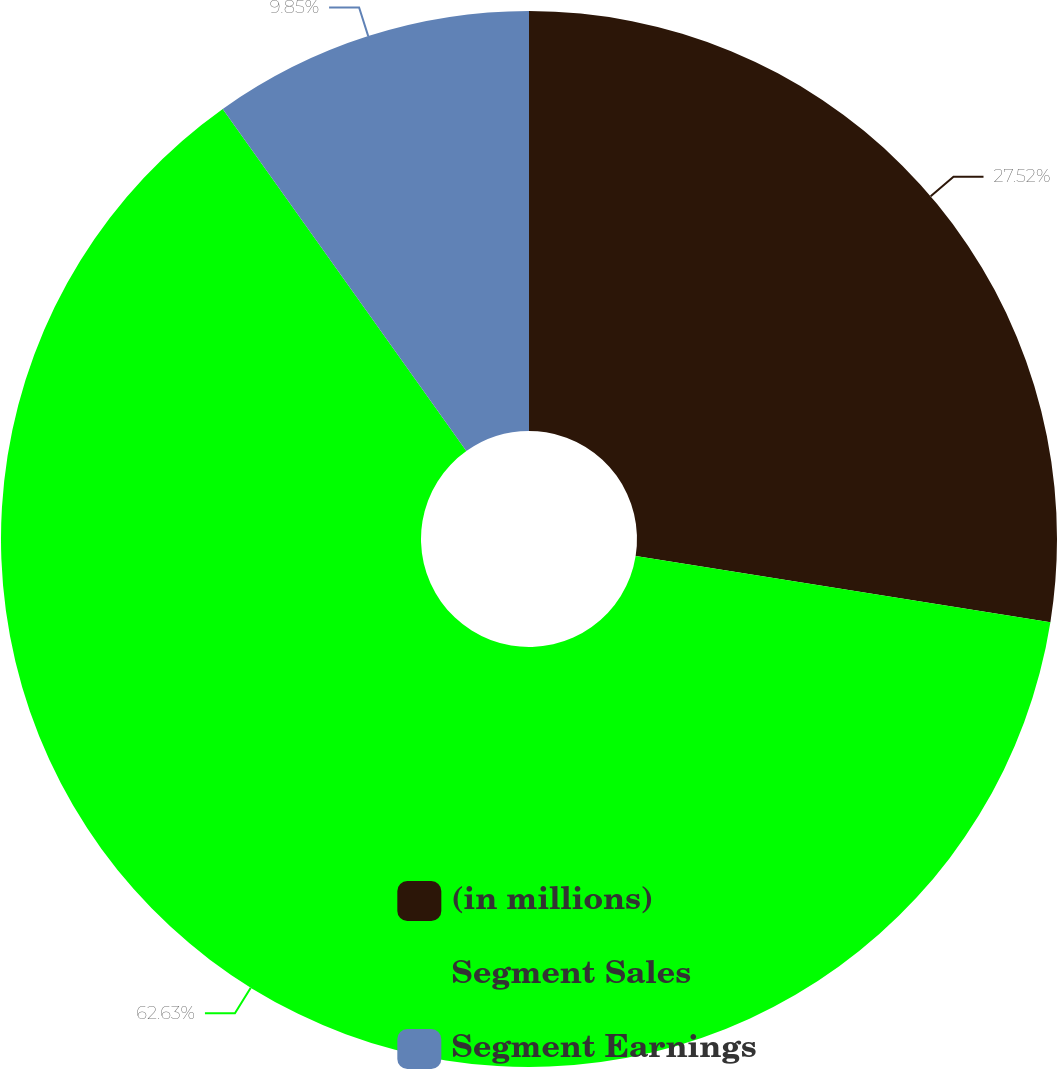Convert chart to OTSL. <chart><loc_0><loc_0><loc_500><loc_500><pie_chart><fcel>(in millions)<fcel>Segment Sales<fcel>Segment Earnings<nl><fcel>27.52%<fcel>62.64%<fcel>9.85%<nl></chart> 